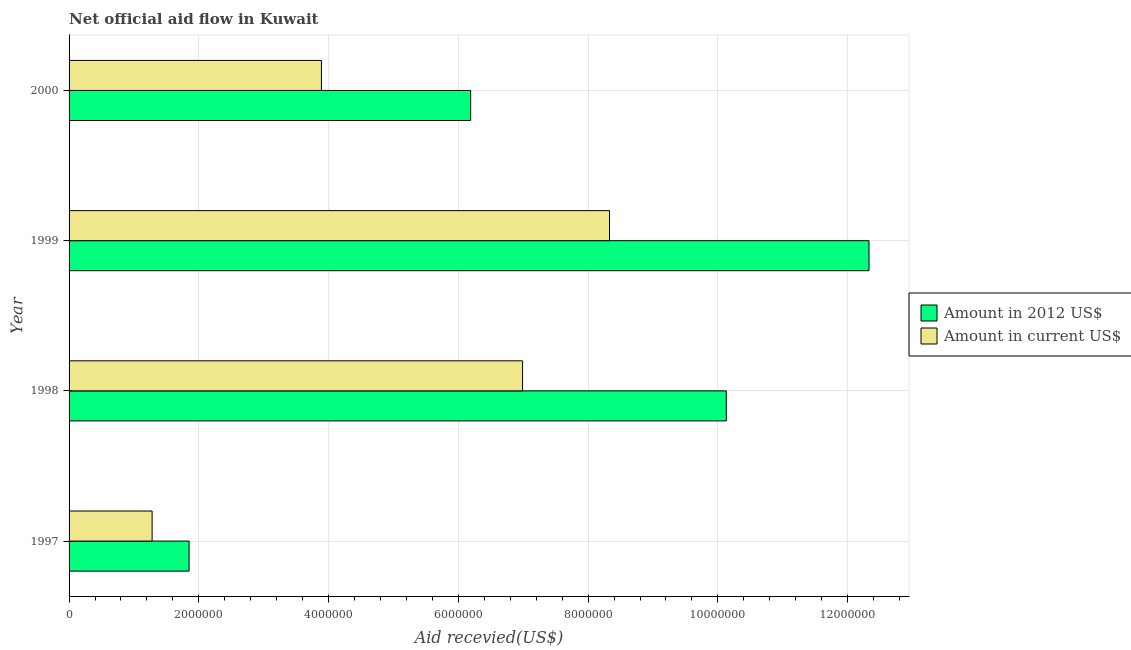How many groups of bars are there?
Provide a succinct answer. 4. Are the number of bars per tick equal to the number of legend labels?
Offer a terse response. Yes. How many bars are there on the 1st tick from the top?
Your answer should be compact. 2. What is the label of the 3rd group of bars from the top?
Ensure brevity in your answer.  1998. In how many cases, is the number of bars for a given year not equal to the number of legend labels?
Provide a short and direct response. 0. What is the amount of aid received(expressed in 2012 us$) in 1998?
Your response must be concise. 1.01e+07. Across all years, what is the maximum amount of aid received(expressed in us$)?
Your answer should be very brief. 8.33e+06. Across all years, what is the minimum amount of aid received(expressed in 2012 us$)?
Offer a terse response. 1.85e+06. In which year was the amount of aid received(expressed in us$) maximum?
Your answer should be very brief. 1999. In which year was the amount of aid received(expressed in us$) minimum?
Your answer should be compact. 1997. What is the total amount of aid received(expressed in 2012 us$) in the graph?
Your answer should be compact. 3.05e+07. What is the difference between the amount of aid received(expressed in 2012 us$) in 1997 and that in 1999?
Ensure brevity in your answer.  -1.05e+07. What is the difference between the amount of aid received(expressed in us$) in 1999 and the amount of aid received(expressed in 2012 us$) in 1997?
Your response must be concise. 6.48e+06. What is the average amount of aid received(expressed in 2012 us$) per year?
Your answer should be compact. 7.62e+06. In the year 1999, what is the difference between the amount of aid received(expressed in 2012 us$) and amount of aid received(expressed in us$)?
Give a very brief answer. 4.00e+06. What is the difference between the highest and the second highest amount of aid received(expressed in 2012 us$)?
Keep it short and to the point. 2.20e+06. What is the difference between the highest and the lowest amount of aid received(expressed in us$)?
Provide a short and direct response. 7.05e+06. In how many years, is the amount of aid received(expressed in us$) greater than the average amount of aid received(expressed in us$) taken over all years?
Your answer should be compact. 2. What does the 1st bar from the top in 1999 represents?
Give a very brief answer. Amount in current US$. What does the 2nd bar from the bottom in 1997 represents?
Give a very brief answer. Amount in current US$. How many bars are there?
Provide a succinct answer. 8. Are all the bars in the graph horizontal?
Offer a very short reply. Yes. How many years are there in the graph?
Your answer should be very brief. 4. What is the difference between two consecutive major ticks on the X-axis?
Make the answer very short. 2.00e+06. Are the values on the major ticks of X-axis written in scientific E-notation?
Your response must be concise. No. Does the graph contain any zero values?
Make the answer very short. No. Does the graph contain grids?
Offer a very short reply. Yes. What is the title of the graph?
Offer a very short reply. Net official aid flow in Kuwait. What is the label or title of the X-axis?
Keep it short and to the point. Aid recevied(US$). What is the label or title of the Y-axis?
Keep it short and to the point. Year. What is the Aid recevied(US$) of Amount in 2012 US$ in 1997?
Ensure brevity in your answer.  1.85e+06. What is the Aid recevied(US$) in Amount in current US$ in 1997?
Ensure brevity in your answer.  1.28e+06. What is the Aid recevied(US$) in Amount in 2012 US$ in 1998?
Your answer should be very brief. 1.01e+07. What is the Aid recevied(US$) of Amount in current US$ in 1998?
Your response must be concise. 6.99e+06. What is the Aid recevied(US$) in Amount in 2012 US$ in 1999?
Make the answer very short. 1.23e+07. What is the Aid recevied(US$) in Amount in current US$ in 1999?
Provide a short and direct response. 8.33e+06. What is the Aid recevied(US$) in Amount in 2012 US$ in 2000?
Offer a very short reply. 6.19e+06. What is the Aid recevied(US$) in Amount in current US$ in 2000?
Offer a very short reply. 3.89e+06. Across all years, what is the maximum Aid recevied(US$) of Amount in 2012 US$?
Provide a succinct answer. 1.23e+07. Across all years, what is the maximum Aid recevied(US$) of Amount in current US$?
Your answer should be compact. 8.33e+06. Across all years, what is the minimum Aid recevied(US$) of Amount in 2012 US$?
Your response must be concise. 1.85e+06. Across all years, what is the minimum Aid recevied(US$) in Amount in current US$?
Your answer should be compact. 1.28e+06. What is the total Aid recevied(US$) in Amount in 2012 US$ in the graph?
Make the answer very short. 3.05e+07. What is the total Aid recevied(US$) of Amount in current US$ in the graph?
Your answer should be compact. 2.05e+07. What is the difference between the Aid recevied(US$) in Amount in 2012 US$ in 1997 and that in 1998?
Your response must be concise. -8.28e+06. What is the difference between the Aid recevied(US$) of Amount in current US$ in 1997 and that in 1998?
Offer a terse response. -5.71e+06. What is the difference between the Aid recevied(US$) of Amount in 2012 US$ in 1997 and that in 1999?
Give a very brief answer. -1.05e+07. What is the difference between the Aid recevied(US$) in Amount in current US$ in 1997 and that in 1999?
Your answer should be very brief. -7.05e+06. What is the difference between the Aid recevied(US$) of Amount in 2012 US$ in 1997 and that in 2000?
Keep it short and to the point. -4.34e+06. What is the difference between the Aid recevied(US$) in Amount in current US$ in 1997 and that in 2000?
Provide a succinct answer. -2.61e+06. What is the difference between the Aid recevied(US$) of Amount in 2012 US$ in 1998 and that in 1999?
Your answer should be very brief. -2.20e+06. What is the difference between the Aid recevied(US$) in Amount in current US$ in 1998 and that in 1999?
Provide a succinct answer. -1.34e+06. What is the difference between the Aid recevied(US$) of Amount in 2012 US$ in 1998 and that in 2000?
Offer a terse response. 3.94e+06. What is the difference between the Aid recevied(US$) of Amount in current US$ in 1998 and that in 2000?
Your answer should be compact. 3.10e+06. What is the difference between the Aid recevied(US$) of Amount in 2012 US$ in 1999 and that in 2000?
Keep it short and to the point. 6.14e+06. What is the difference between the Aid recevied(US$) in Amount in current US$ in 1999 and that in 2000?
Provide a short and direct response. 4.44e+06. What is the difference between the Aid recevied(US$) of Amount in 2012 US$ in 1997 and the Aid recevied(US$) of Amount in current US$ in 1998?
Provide a succinct answer. -5.14e+06. What is the difference between the Aid recevied(US$) of Amount in 2012 US$ in 1997 and the Aid recevied(US$) of Amount in current US$ in 1999?
Provide a short and direct response. -6.48e+06. What is the difference between the Aid recevied(US$) in Amount in 2012 US$ in 1997 and the Aid recevied(US$) in Amount in current US$ in 2000?
Ensure brevity in your answer.  -2.04e+06. What is the difference between the Aid recevied(US$) in Amount in 2012 US$ in 1998 and the Aid recevied(US$) in Amount in current US$ in 1999?
Make the answer very short. 1.80e+06. What is the difference between the Aid recevied(US$) in Amount in 2012 US$ in 1998 and the Aid recevied(US$) in Amount in current US$ in 2000?
Keep it short and to the point. 6.24e+06. What is the difference between the Aid recevied(US$) of Amount in 2012 US$ in 1999 and the Aid recevied(US$) of Amount in current US$ in 2000?
Give a very brief answer. 8.44e+06. What is the average Aid recevied(US$) of Amount in 2012 US$ per year?
Your answer should be compact. 7.62e+06. What is the average Aid recevied(US$) of Amount in current US$ per year?
Your answer should be compact. 5.12e+06. In the year 1997, what is the difference between the Aid recevied(US$) of Amount in 2012 US$ and Aid recevied(US$) of Amount in current US$?
Offer a terse response. 5.70e+05. In the year 1998, what is the difference between the Aid recevied(US$) of Amount in 2012 US$ and Aid recevied(US$) of Amount in current US$?
Offer a terse response. 3.14e+06. In the year 1999, what is the difference between the Aid recevied(US$) of Amount in 2012 US$ and Aid recevied(US$) of Amount in current US$?
Offer a very short reply. 4.00e+06. In the year 2000, what is the difference between the Aid recevied(US$) in Amount in 2012 US$ and Aid recevied(US$) in Amount in current US$?
Give a very brief answer. 2.30e+06. What is the ratio of the Aid recevied(US$) in Amount in 2012 US$ in 1997 to that in 1998?
Your answer should be very brief. 0.18. What is the ratio of the Aid recevied(US$) of Amount in current US$ in 1997 to that in 1998?
Offer a terse response. 0.18. What is the ratio of the Aid recevied(US$) of Amount in current US$ in 1997 to that in 1999?
Give a very brief answer. 0.15. What is the ratio of the Aid recevied(US$) in Amount in 2012 US$ in 1997 to that in 2000?
Offer a terse response. 0.3. What is the ratio of the Aid recevied(US$) in Amount in current US$ in 1997 to that in 2000?
Ensure brevity in your answer.  0.33. What is the ratio of the Aid recevied(US$) in Amount in 2012 US$ in 1998 to that in 1999?
Provide a succinct answer. 0.82. What is the ratio of the Aid recevied(US$) in Amount in current US$ in 1998 to that in 1999?
Keep it short and to the point. 0.84. What is the ratio of the Aid recevied(US$) in Amount in 2012 US$ in 1998 to that in 2000?
Offer a very short reply. 1.64. What is the ratio of the Aid recevied(US$) in Amount in current US$ in 1998 to that in 2000?
Your response must be concise. 1.8. What is the ratio of the Aid recevied(US$) of Amount in 2012 US$ in 1999 to that in 2000?
Your answer should be very brief. 1.99. What is the ratio of the Aid recevied(US$) in Amount in current US$ in 1999 to that in 2000?
Your answer should be very brief. 2.14. What is the difference between the highest and the second highest Aid recevied(US$) of Amount in 2012 US$?
Give a very brief answer. 2.20e+06. What is the difference between the highest and the second highest Aid recevied(US$) in Amount in current US$?
Your answer should be very brief. 1.34e+06. What is the difference between the highest and the lowest Aid recevied(US$) of Amount in 2012 US$?
Give a very brief answer. 1.05e+07. What is the difference between the highest and the lowest Aid recevied(US$) of Amount in current US$?
Provide a succinct answer. 7.05e+06. 